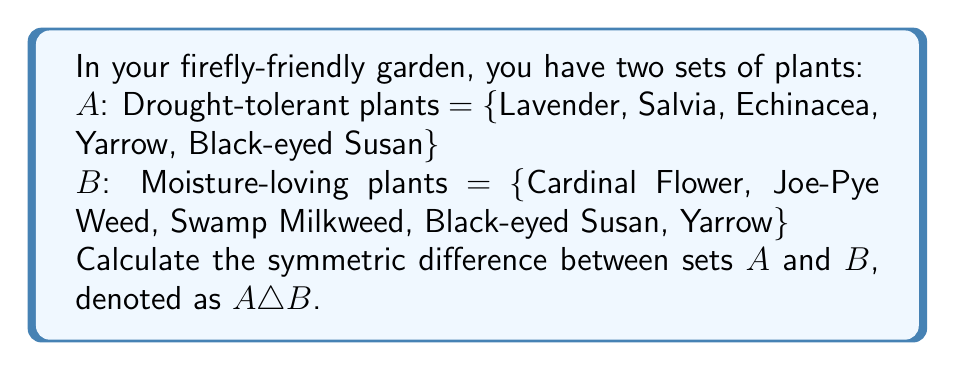Teach me how to tackle this problem. To find the symmetric difference between two sets, we need to determine the elements that are in either set, but not in both. Mathematically, this is expressed as:

$A \triangle B = (A \setminus B) \cup (B \setminus A)$

Let's break this down step-by-step:

1. First, find $A \setminus B$ (elements in $A$ but not in $B$):
   $A \setminus B = \{Lavender, Salvia, Echinacea\}$

2. Next, find $B \setminus A$ (elements in $B$ but not in $A$):
   $B \setminus A = \{Cardinal Flower, Joe-Pye Weed, Swamp Milkweed\}$

3. Now, we take the union of these two sets:
   $(A \setminus B) \cup (B \setminus A) = \{Lavender, Salvia, Echinacea, Cardinal Flower, Joe-Pye Weed, Swamp Milkweed\}$

Note that Black-eyed Susan and Yarrow are in both sets $A$ and $B$, so they are not included in the symmetric difference.
Answer: $A \triangle B = \{Lavender, Salvia, Echinacea, Cardinal Flower, Joe-Pye Weed, Swamp Milkweed\}$ 